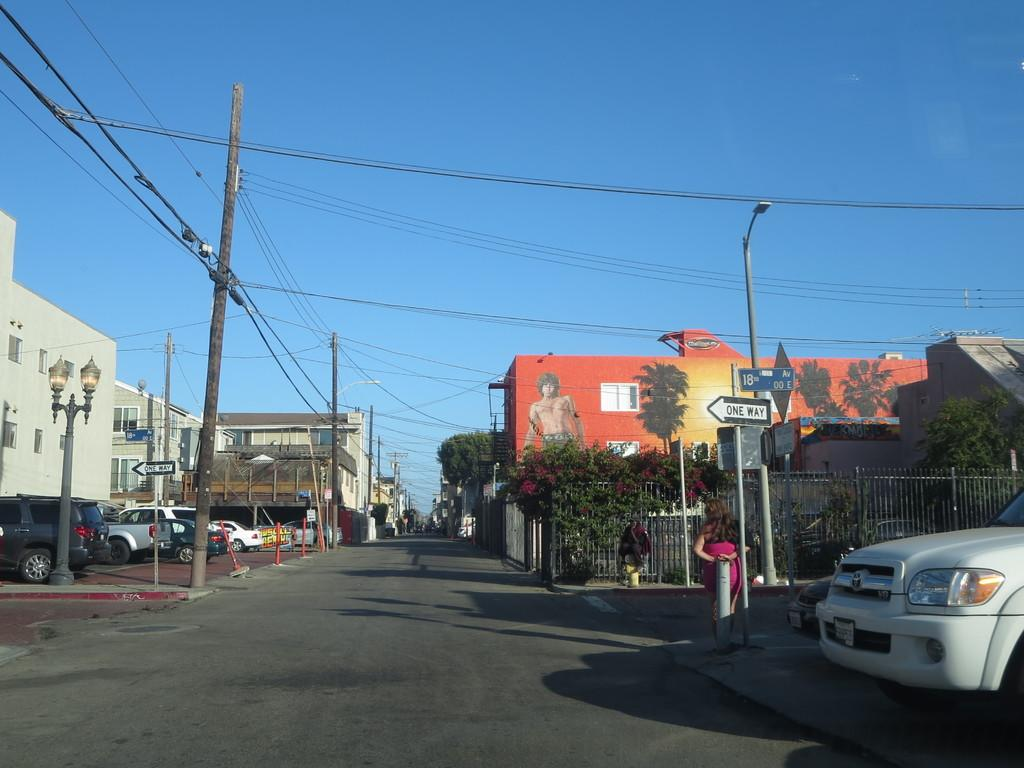What is located on the right side of the image? There is a car parked on the right side of the image. What can be seen on the left side of the image? There are buildings on the left side of the image. What is visible at the top of the image? The sky is visible at the top of the image. How would you describe the weather based on the sky in the image? The sky appears to be sunny, suggesting good weather. Where is the ornament hanging in the image? There is no ornament present in the image. How many cherries are on the car in the image? There are no cherries present in the image; it features a car parked on the right side. 